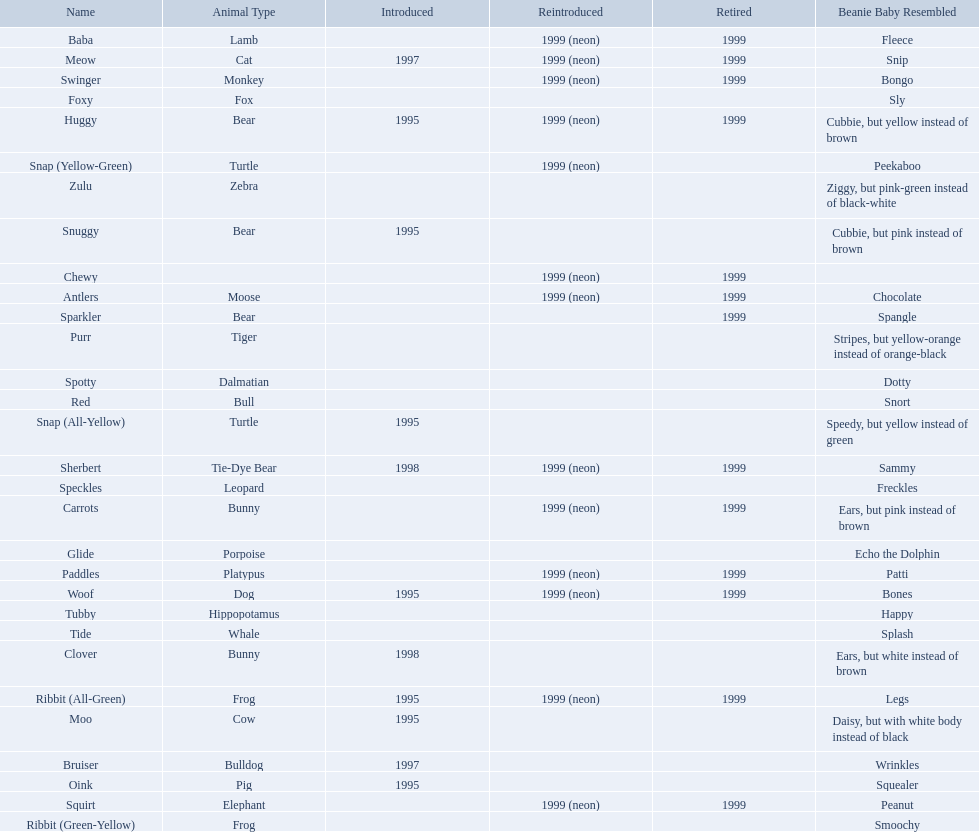What animals are pillow pals? Moose, Lamb, Bulldog, Bunny, Bunny, Fox, Porpoise, Bear, Cat, Cow, Pig, Platypus, Tiger, Bull, Frog, Frog, Tie-Dye Bear, Turtle, Turtle, Bear, Bear, Leopard, Dalmatian, Elephant, Monkey, Whale, Hippopotamus, Dog, Zebra. What is the name of the dalmatian? Spotty. 